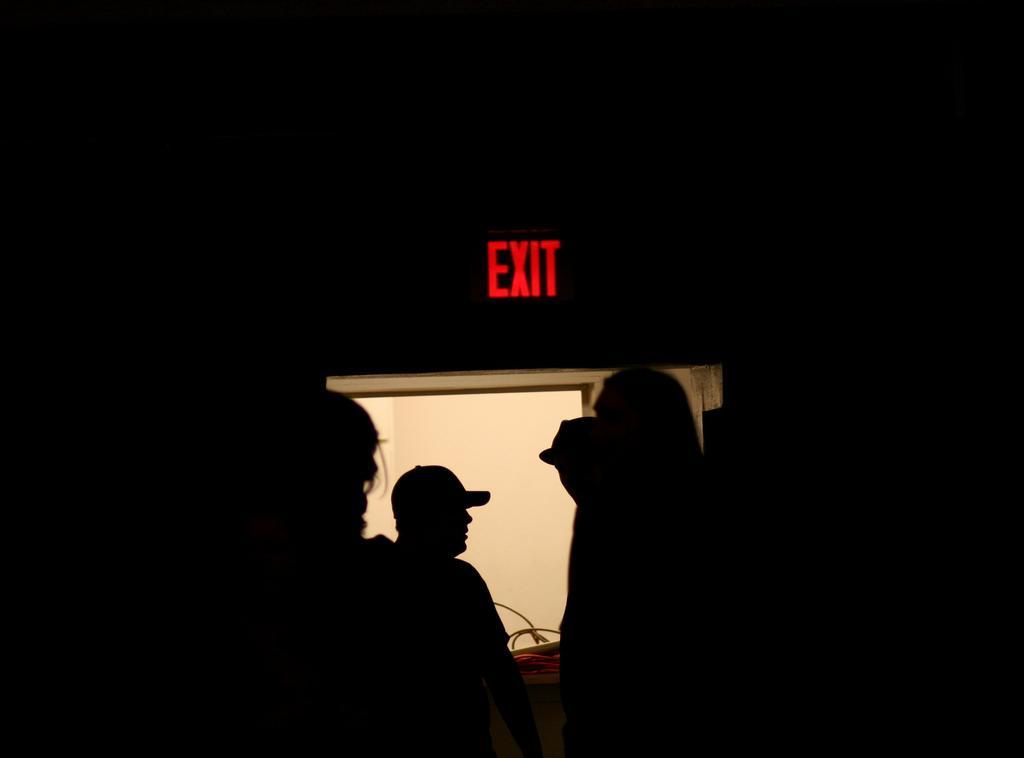Can you describe this image briefly? In this image I can see few people, exit board and dark background. 